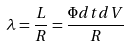<formula> <loc_0><loc_0><loc_500><loc_500>\lambda = \frac { L } { R } = \frac { \Phi d t d V } { R }</formula> 